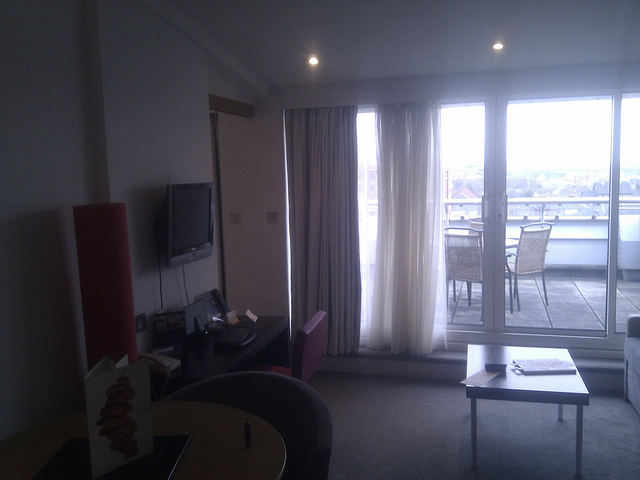<image>What bridge can be seen in the distance? I don't know what bridge can be seen in the distance. It could possibly be the Golden Gate or Brooklyn bridge. What color is the place mat? There is no place mat in the image. However, if there was one, it could be gray, black, white, or blue. What color is the place mat? There is no place mat in the image. What bridge can be seen in the distance? I don't know what bridge can be seen in the distance. It can be either "cement one", "san francisco bridge", "golden gate", "london", or "brooklyn". 